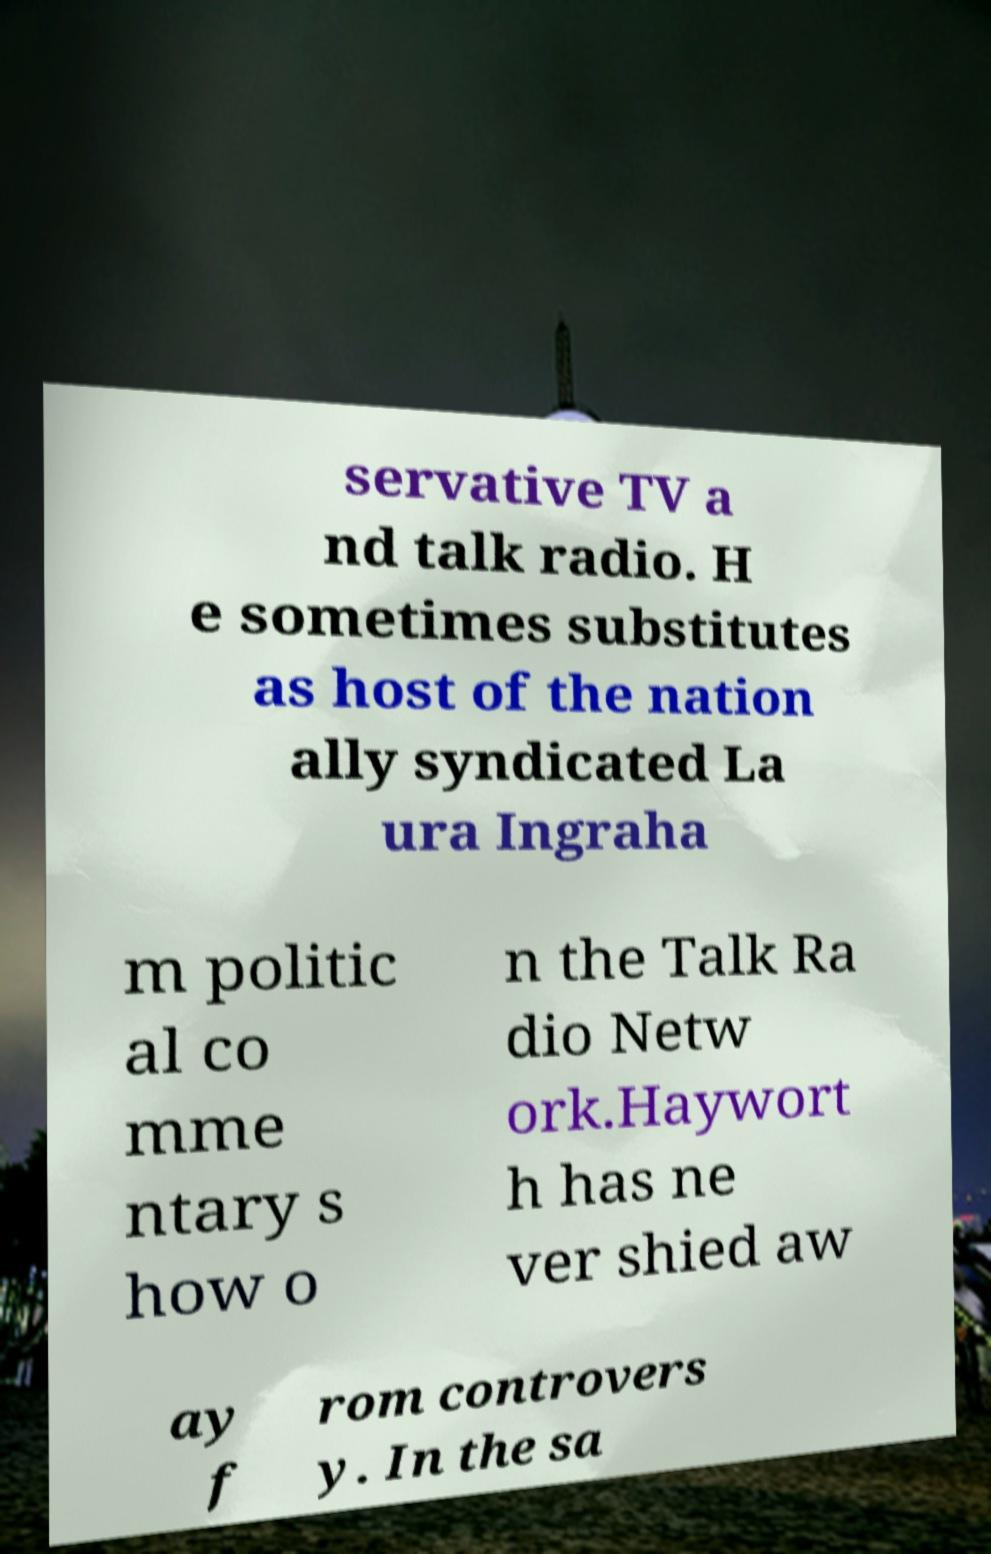What messages or text are displayed in this image? I need them in a readable, typed format. servative TV a nd talk radio. H e sometimes substitutes as host of the nation ally syndicated La ura Ingraha m politic al co mme ntary s how o n the Talk Ra dio Netw ork.Haywort h has ne ver shied aw ay f rom controvers y. In the sa 